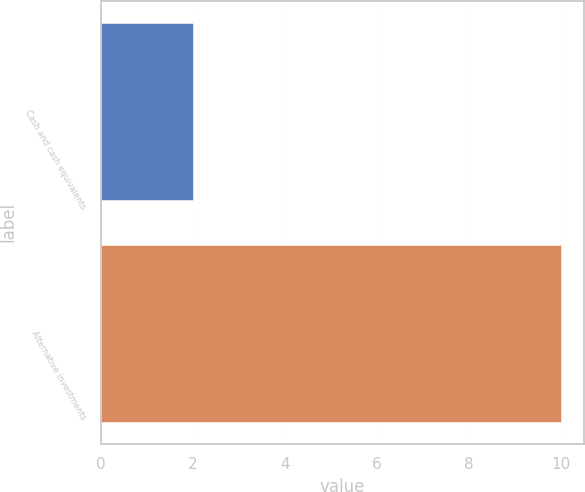Convert chart to OTSL. <chart><loc_0><loc_0><loc_500><loc_500><bar_chart><fcel>Cash and cash equivalents<fcel>Alternative investments<nl><fcel>2<fcel>10<nl></chart> 